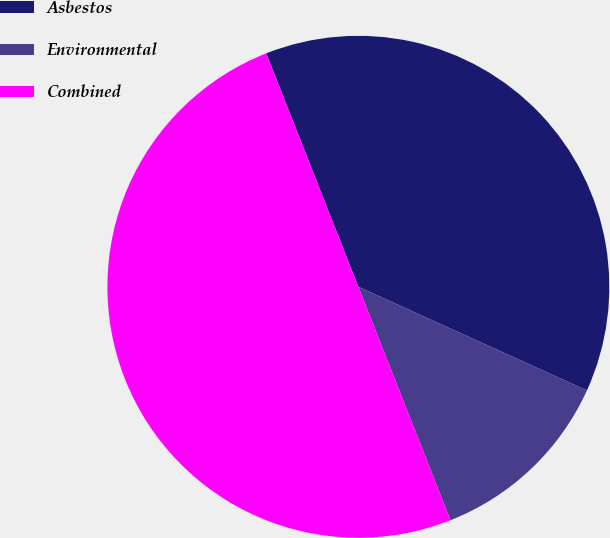Convert chart to OTSL. <chart><loc_0><loc_0><loc_500><loc_500><pie_chart><fcel>Asbestos<fcel>Environmental<fcel>Combined<nl><fcel>37.76%<fcel>12.24%<fcel>50.0%<nl></chart> 